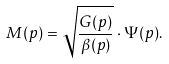<formula> <loc_0><loc_0><loc_500><loc_500>M ( p ) = \sqrt { \frac { G ( p ) } { \beta ( p ) } } \cdot \Psi ( p ) .</formula> 